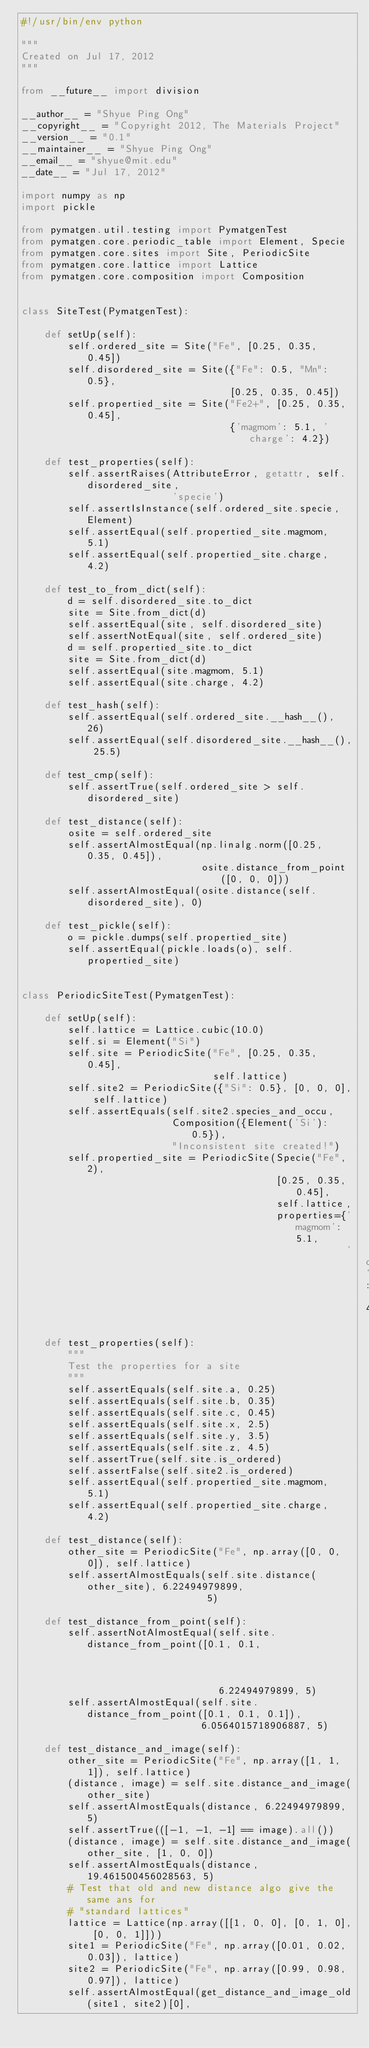<code> <loc_0><loc_0><loc_500><loc_500><_Python_>#!/usr/bin/env python

"""
Created on Jul 17, 2012
"""

from __future__ import division

__author__ = "Shyue Ping Ong"
__copyright__ = "Copyright 2012, The Materials Project"
__version__ = "0.1"
__maintainer__ = "Shyue Ping Ong"
__email__ = "shyue@mit.edu"
__date__ = "Jul 17, 2012"

import numpy as np
import pickle

from pymatgen.util.testing import PymatgenTest
from pymatgen.core.periodic_table import Element, Specie
from pymatgen.core.sites import Site, PeriodicSite
from pymatgen.core.lattice import Lattice
from pymatgen.core.composition import Composition


class SiteTest(PymatgenTest):

    def setUp(self):
        self.ordered_site = Site("Fe", [0.25, 0.35, 0.45])
        self.disordered_site = Site({"Fe": 0.5, "Mn": 0.5},
                                    [0.25, 0.35, 0.45])
        self.propertied_site = Site("Fe2+", [0.25, 0.35, 0.45],
                                    {'magmom': 5.1, 'charge': 4.2})

    def test_properties(self):
        self.assertRaises(AttributeError, getattr, self.disordered_site,
                          'specie')
        self.assertIsInstance(self.ordered_site.specie, Element)
        self.assertEqual(self.propertied_site.magmom, 5.1)
        self.assertEqual(self.propertied_site.charge, 4.2)

    def test_to_from_dict(self):
        d = self.disordered_site.to_dict
        site = Site.from_dict(d)
        self.assertEqual(site, self.disordered_site)
        self.assertNotEqual(site, self.ordered_site)
        d = self.propertied_site.to_dict
        site = Site.from_dict(d)
        self.assertEqual(site.magmom, 5.1)
        self.assertEqual(site.charge, 4.2)

    def test_hash(self):
        self.assertEqual(self.ordered_site.__hash__(), 26)
        self.assertEqual(self.disordered_site.__hash__(), 25.5)

    def test_cmp(self):
        self.assertTrue(self.ordered_site > self.disordered_site)

    def test_distance(self):
        osite = self.ordered_site
        self.assertAlmostEqual(np.linalg.norm([0.25, 0.35, 0.45]),
                               osite.distance_from_point([0, 0, 0]))
        self.assertAlmostEqual(osite.distance(self.disordered_site), 0)

    def test_pickle(self):
        o = pickle.dumps(self.propertied_site)
        self.assertEqual(pickle.loads(o), self.propertied_site)


class PeriodicSiteTest(PymatgenTest):

    def setUp(self):
        self.lattice = Lattice.cubic(10.0)
        self.si = Element("Si")
        self.site = PeriodicSite("Fe", [0.25, 0.35, 0.45],
                                 self.lattice)
        self.site2 = PeriodicSite({"Si": 0.5}, [0, 0, 0], self.lattice)
        self.assertEquals(self.site2.species_and_occu,
                          Composition({Element('Si'): 0.5}),
                          "Inconsistent site created!")
        self.propertied_site = PeriodicSite(Specie("Fe", 2),
                                            [0.25, 0.35, 0.45],
                                            self.lattice,
                                            properties={'magmom': 5.1,
                                                        'charge': 4.2})

    def test_properties(self):
        """
        Test the properties for a site
        """
        self.assertEquals(self.site.a, 0.25)
        self.assertEquals(self.site.b, 0.35)
        self.assertEquals(self.site.c, 0.45)
        self.assertEquals(self.site.x, 2.5)
        self.assertEquals(self.site.y, 3.5)
        self.assertEquals(self.site.z, 4.5)
        self.assertTrue(self.site.is_ordered)
        self.assertFalse(self.site2.is_ordered)
        self.assertEqual(self.propertied_site.magmom, 5.1)
        self.assertEqual(self.propertied_site.charge, 4.2)

    def test_distance(self):
        other_site = PeriodicSite("Fe", np.array([0, 0, 0]), self.lattice)
        self.assertAlmostEquals(self.site.distance(other_site), 6.22494979899,
                                5)

    def test_distance_from_point(self):
        self.assertNotAlmostEqual(self.site.distance_from_point([0.1, 0.1,
                                                                 0.1]),
                                  6.22494979899, 5)
        self.assertAlmostEqual(self.site.distance_from_point([0.1, 0.1, 0.1]),
                               6.0564015718906887, 5)

    def test_distance_and_image(self):
        other_site = PeriodicSite("Fe", np.array([1, 1, 1]), self.lattice)
        (distance, image) = self.site.distance_and_image(other_site)
        self.assertAlmostEquals(distance, 6.22494979899, 5)
        self.assertTrue(([-1, -1, -1] == image).all())
        (distance, image) = self.site.distance_and_image(other_site, [1, 0, 0])
        self.assertAlmostEquals(distance, 19.461500456028563, 5)
        # Test that old and new distance algo give the same ans for
        # "standard lattices"
        lattice = Lattice(np.array([[1, 0, 0], [0, 1, 0], [0, 0, 1]]))
        site1 = PeriodicSite("Fe", np.array([0.01, 0.02, 0.03]), lattice)
        site2 = PeriodicSite("Fe", np.array([0.99, 0.98, 0.97]), lattice)
        self.assertAlmostEqual(get_distance_and_image_old(site1, site2)[0],</code> 